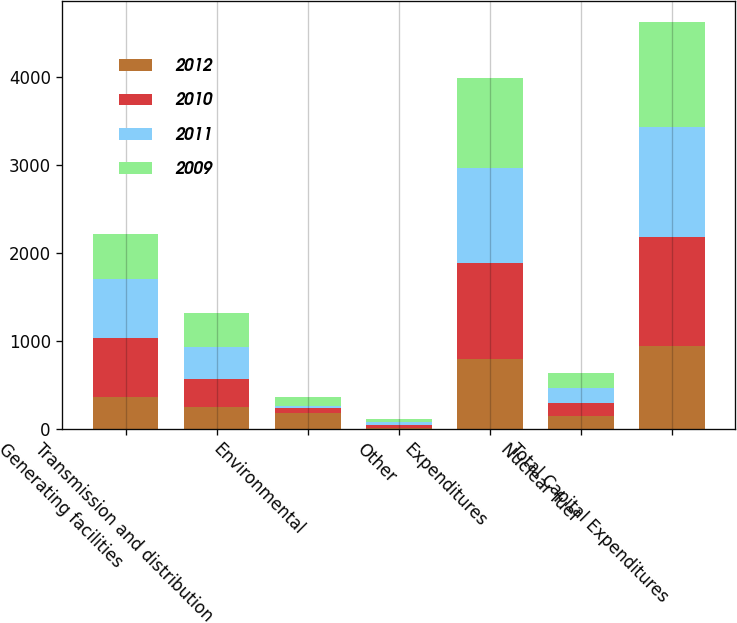Convert chart. <chart><loc_0><loc_0><loc_500><loc_500><stacked_bar_chart><ecel><fcel>Generating facilities<fcel>Transmission and distribution<fcel>Environmental<fcel>Other<fcel>Expenditures<fcel>Nuclear fuel<fcel>Total Capital Expenditures<nl><fcel>2012<fcel>361<fcel>247<fcel>178<fcel>11<fcel>797<fcel>140<fcel>937<nl><fcel>2010<fcel>671<fcel>320<fcel>63<fcel>31<fcel>1085<fcel>151<fcel>1236<nl><fcel>2011<fcel>673<fcel>358<fcel>19<fcel>33<fcel>1083<fcel>173<fcel>1256<nl><fcel>2009<fcel>507<fcel>385<fcel>99<fcel>31<fcel>1022<fcel>171<fcel>1193<nl></chart> 